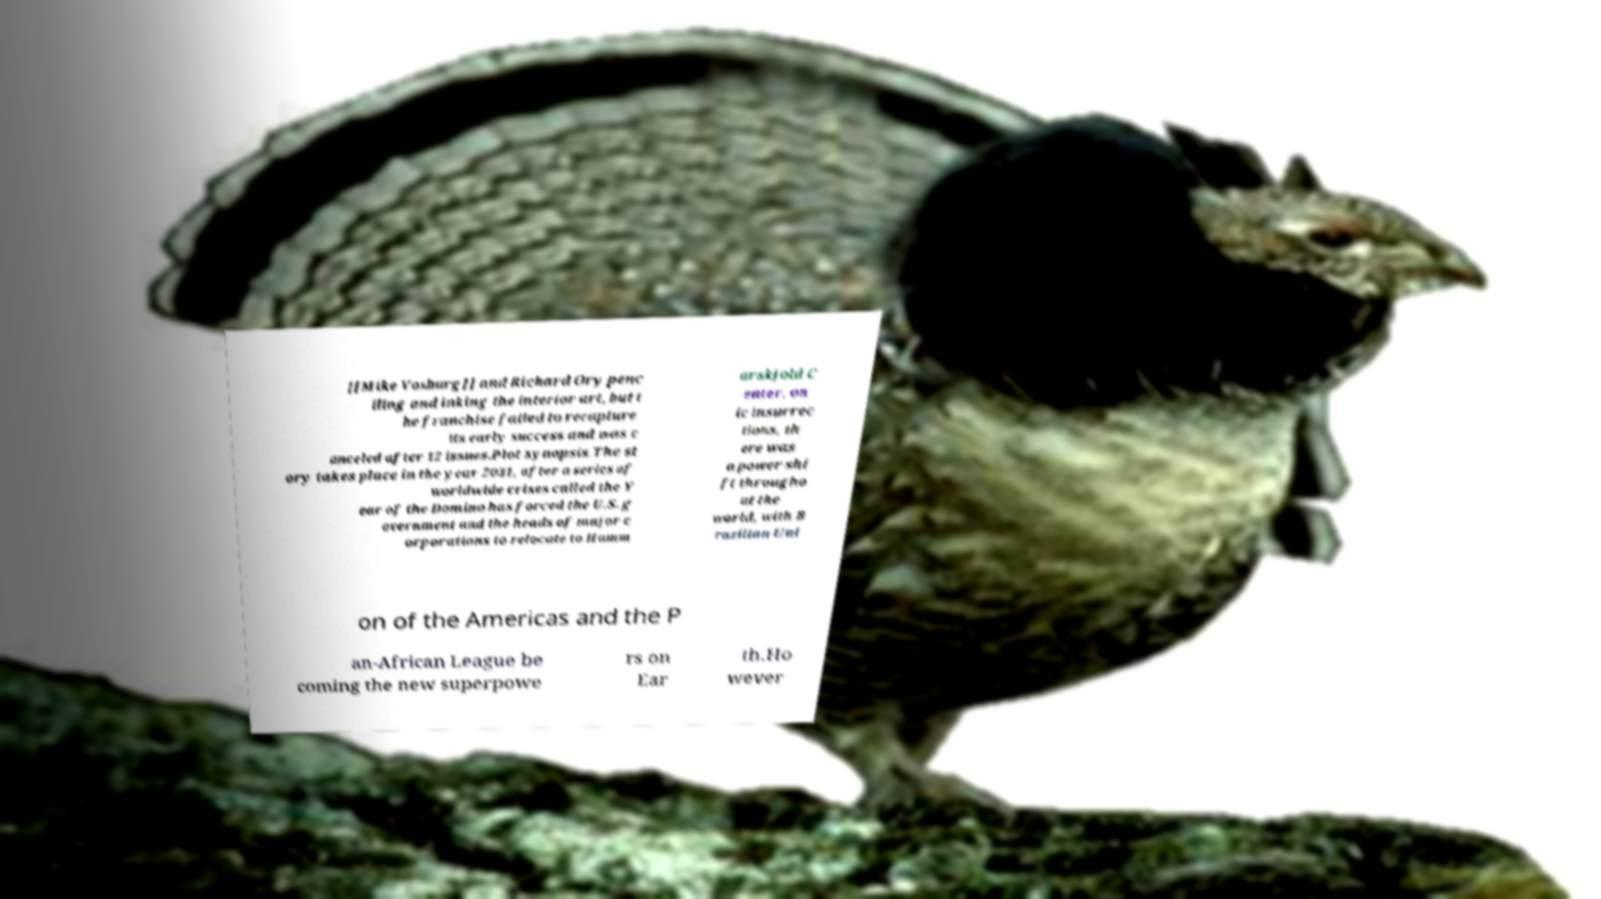There's text embedded in this image that I need extracted. Can you transcribe it verbatim? [[Mike Vosburg]] and Richard Ory penc iling and inking the interior art, but t he franchise failed to recapture its early success and was c anceled after 12 issues.Plot synopsis.The st ory takes place in the year 2031, after a series of worldwide crises called the Y ear of the Domino has forced the U.S. g overnment and the heads of major c orporations to relocate to Hamm arskjold C enter, on ic insurrec tions, th ere was a power shi ft througho ut the world, with B razilian Uni on of the Americas and the P an-African League be coming the new superpowe rs on Ear th.Ho wever 